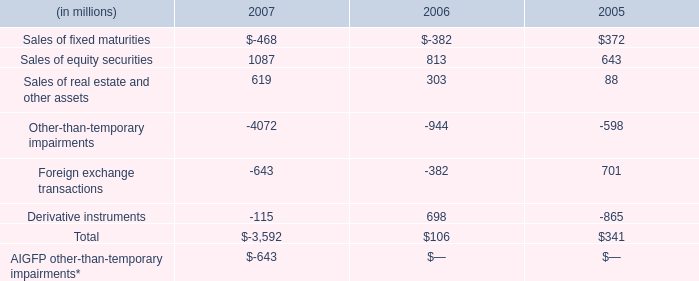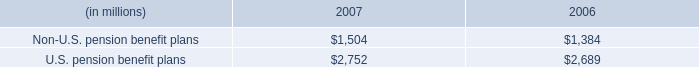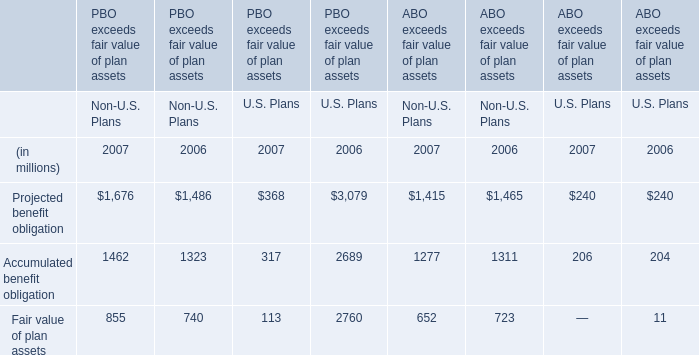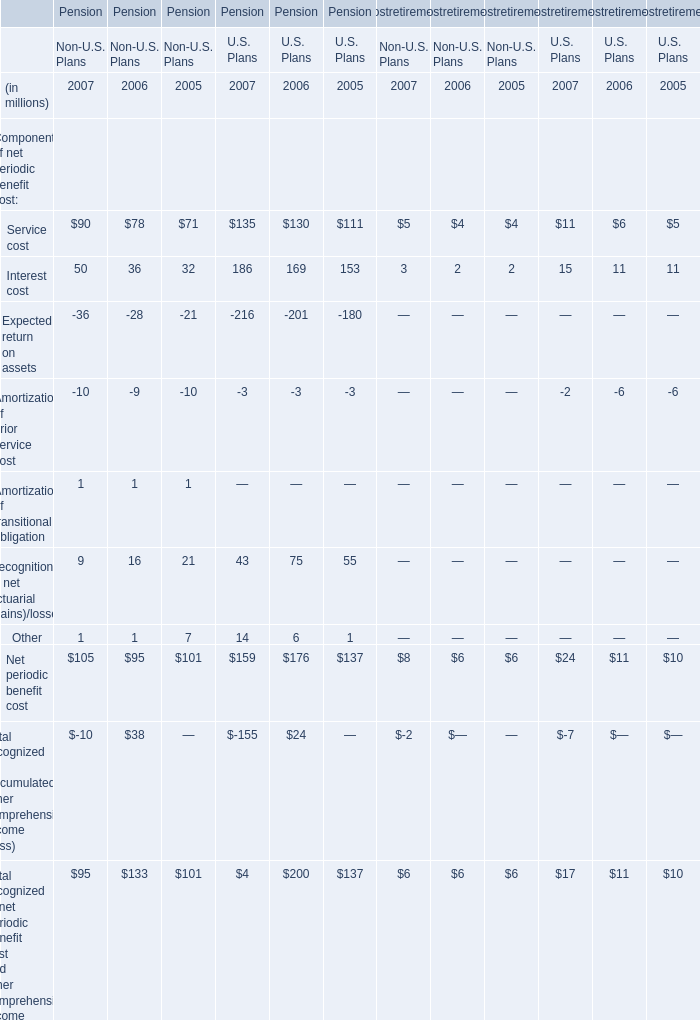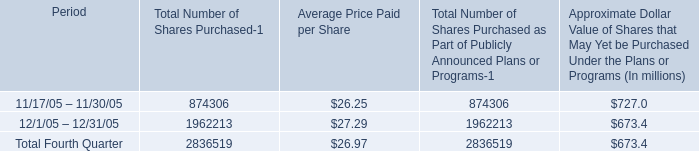What will Non-U.S. Plans be like in 2008 if it continues to grow at the same rate as it did in 2007? (in million) 
Computations: ((((((1676 + 1462) + 855) + 1415) + 1277) + 652) * (1 + ((((((((((((1676 + 1462) + 855) + 1415) + 1277) + 652) - 1486) - 1323) - 740) - 1465) - 1311) - 723) / (((((1486 + 1323) + 740) + 1465) + 1311) + 723))))
Answer: 7637.85031. 